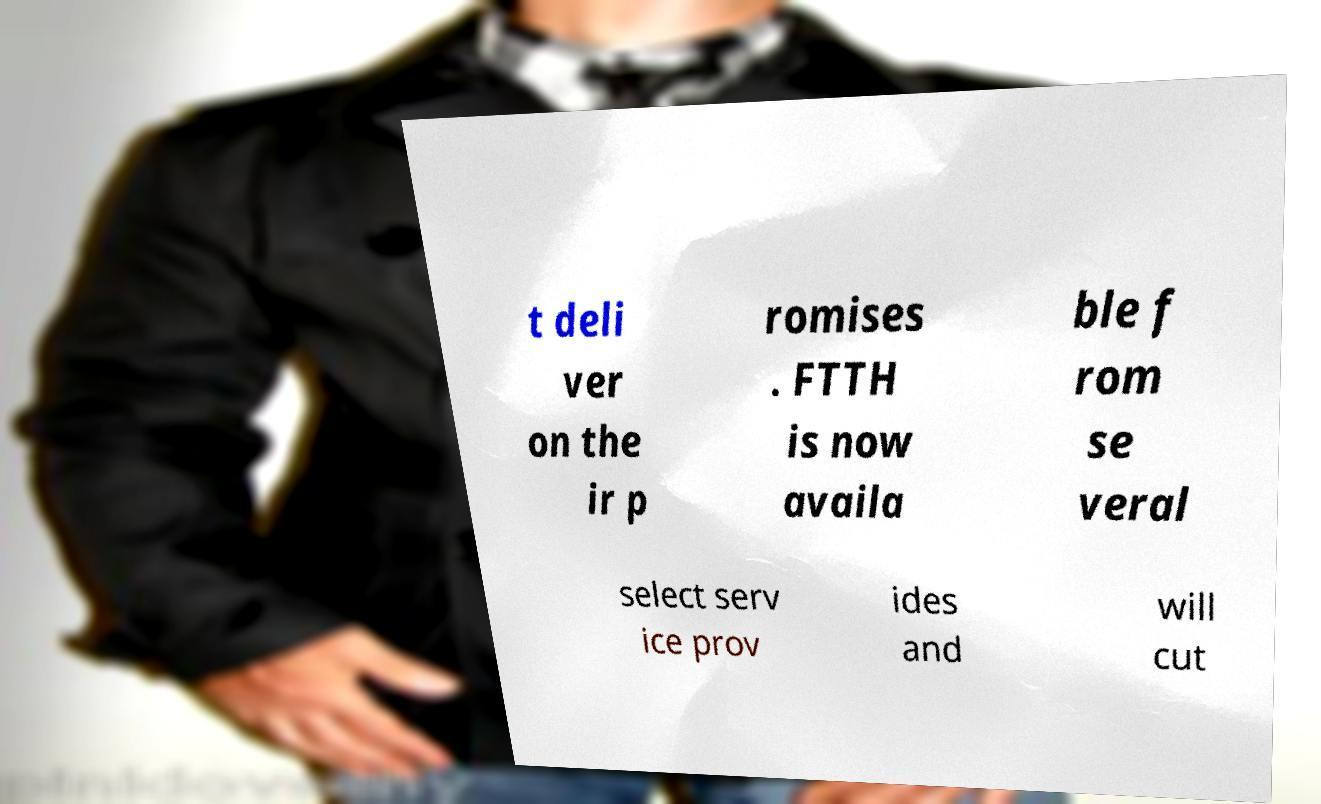Could you extract and type out the text from this image? t deli ver on the ir p romises . FTTH is now availa ble f rom se veral select serv ice prov ides and will cut 